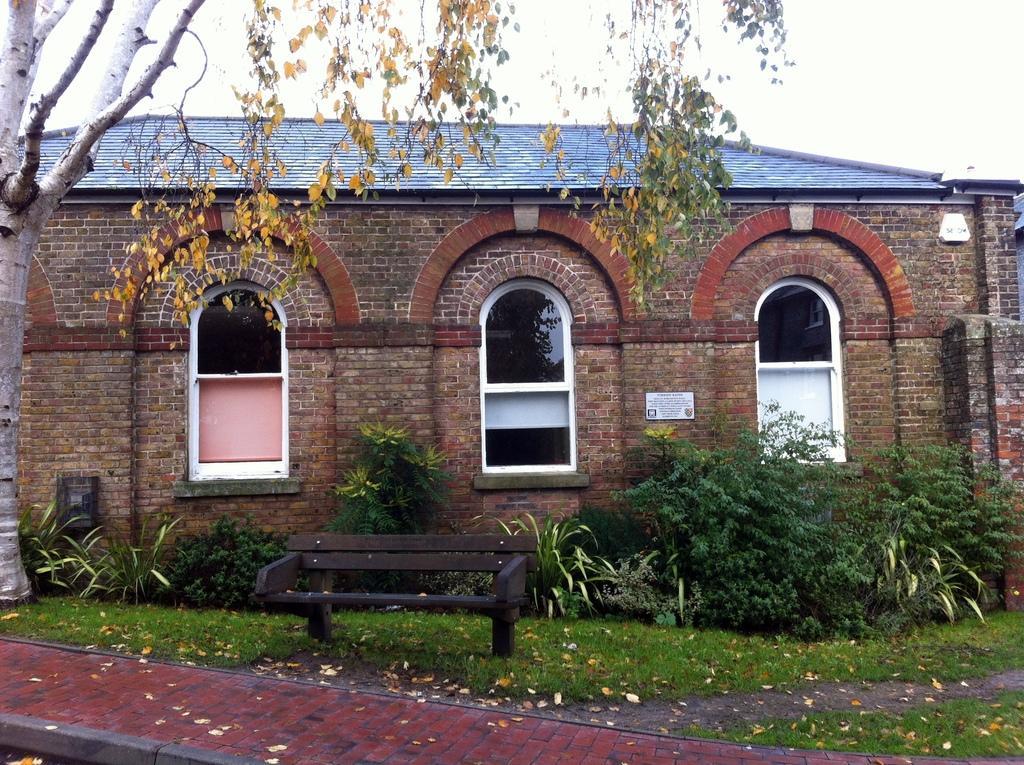Could you give a brief overview of what you see in this image? In this image we can see a building, there are some plants, leaves, windows and grass, also we can see a tree and bench, in the background, we can see the sky. 